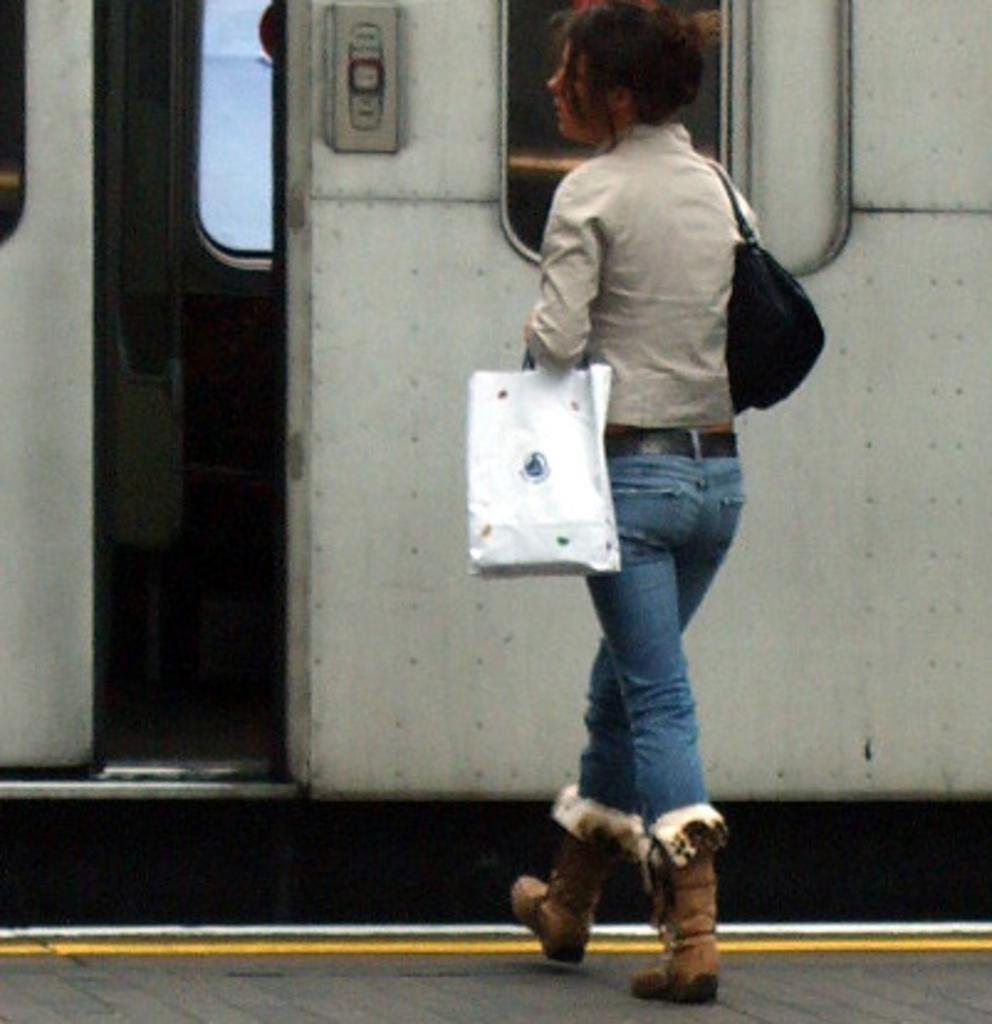Who is the main subject in the image? There is a woman in the image. Where is the woman positioned in the image? The woman is standing in the center of the image. What is the woman carrying in her hands? The woman is carrying a bag and a paper cover in her hands. What can be seen behind the woman in the image? There is a train in front of the woman. How many girls are playing on the dock in the image? There are no girls or docks present in the image; it features a woman standing in front of a train. 